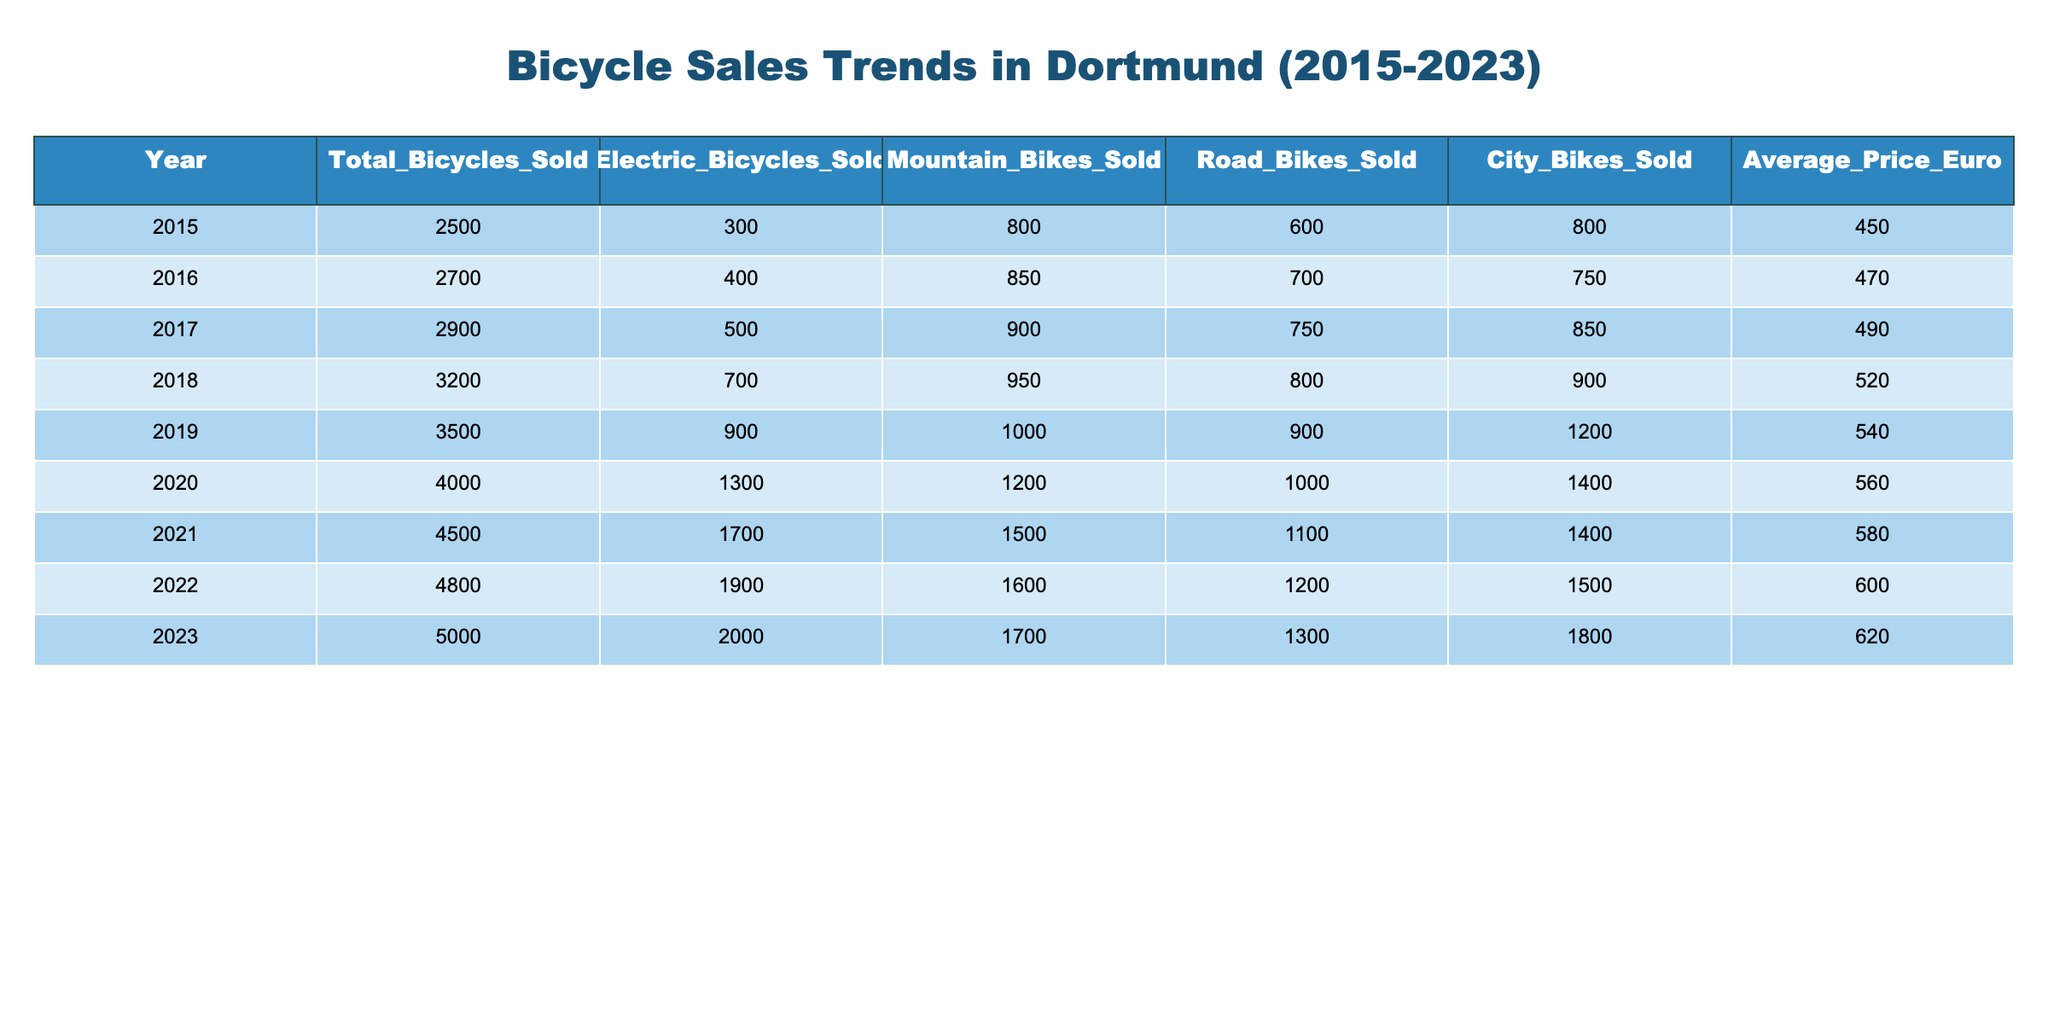What was the total number of bicycles sold in 2020? Referring to the table, the total bicycles sold in 2020 is clearly indicated as 4000.
Answer: 4000 In which year did electric bicycles sales exceed 1000 for the first time? By examining the column for electric bicycles sold, we observe that the sales crossed 1000 between 2019 and 2020. Thus, 2020 is the year when electric bicycles sales first exceeded 1000.
Answer: 2020 How many more mountain bikes were sold in 2023 compared to 2015? The table shows that mountain bikes sold in 2023 was 1700 and in 2015 it was 800. Subtracting these gives 1700 - 800 = 900, indicating that 900 more mountain bikes were sold in 2023 compared to 2015.
Answer: 900 What was the average price of bicycles sold in 2022? The average price of bicycles for 2022 is directly listed in the table as 600 euros.
Answer: 600 Did the total number of bicycles sold in 2021 exceed the total number sold in 2018? Total bicycles sold in 2021 is 4500 while in 2018 it was 3200. Since 4500 is greater than 3200, the statement is true.
Answer: Yes What is the percentage increase in electric bicycle sales from 2019 to 2023? Electric bicycles sold in 2019 was 900 and in 2023 it was 2000. The increase is 2000 - 900 = 1100. To find the percentage increase, we calculate (1100 / 900) * 100 = 122.22% approximately.
Answer: 122.22% What was the total sales of City Bikes from 2015 to 2023? Summing the City Bikes sold each year from 2015 to 2023: 800 + 750 + 850 + 900 + 1200 + 1400 + 1500 + 1800 = 8150. Thus, the total sales of City Bikes during this period is 8150.
Answer: 8150 In which year did the average price of bicycles reach its highest point? Referring to the average price column, we see the prices increase each year and peak at 620 euros in 2023. Therefore, the highest average price was in 2023.
Answer: 2023 How many bicycles were sold in 2016 compared to 2022? The total number of bicycles sold in 2016 is 2700 and in 2022 it is 4800. To determine how many more were sold in 2022, subtract 2700 from 4800 yielding 4800 - 2700 = 2100. Hence, 2100 more bicycles were sold in 2022.
Answer: 2100 